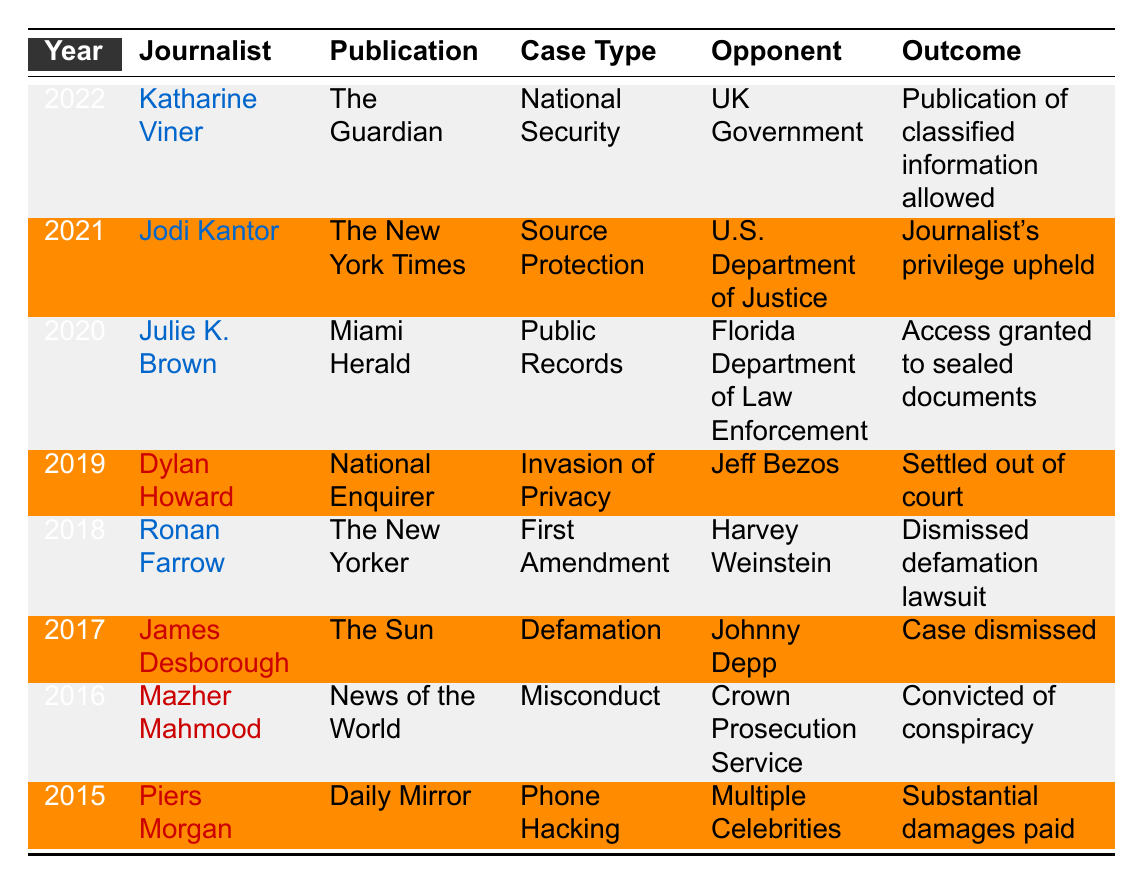What journalist won a case in 2022? Referring to the table, in 2022, the journalist who won a case was Katharine Viner.
Answer: Katharine Viner How many cases were won by ethical journalists? Analyzing the table, there are four cases listed under 'Ethical' journalist type: in 2018, 2020, 2021, and 2022.
Answer: 4 What was the outcome of Julie K. Brown's case? According to the table, Julie K. Brown's case outcome in 2020 was "Access granted to sealed documents."
Answer: Access granted to sealed documents Did any tabloid journalist win a case after 2018? Looking at the table, yes, the tabloid journalist Dylan Howard had a case in 2019 that was settled out of court.
Answer: Yes In what year did Jodi Kantor win her case? By examining the table, Jodi Kantor won her case in 2021.
Answer: 2021 What type of case did Mazher Mahmood deal with? The table indicates that Mazher Mahmood dealt with a "Misconduct" case.
Answer: Misconduct How many tabloid reporters are represented in the table? The table lists three tabloid reporters: Dylan Howard, James Desborough, and Piers Morgan.
Answer: 3 Which journalist dealt with a defamation case involving Johnny Depp? Referring to the table, James Desborough dealt with the defamation case involving Johnny Depp.
Answer: James Desborough Were there more ethical journalist cases won than tabloid cases? Counting the cases, ethical journalists won four cases while tabloid journalists won three cases, so yes.
Answer: Yes What was the outcome for Crown Prosecution Service in Mazher Mahmood's case? According to the table, the outcome for the Crown Prosecution Service in Mazher Mahmood's case was that he was convicted of conspiracy.
Answer: Convicted of conspiracy What can be inferred about the outcomes of cases won by ethical journalists versus tabloid reporters? A deeper analysis shows that ethical journalists had outcomes that favored journalistic integrity, while tabloid reporters often faced settlements or legal consequences.
Answer: Ethical journalists had favorable outcomes 